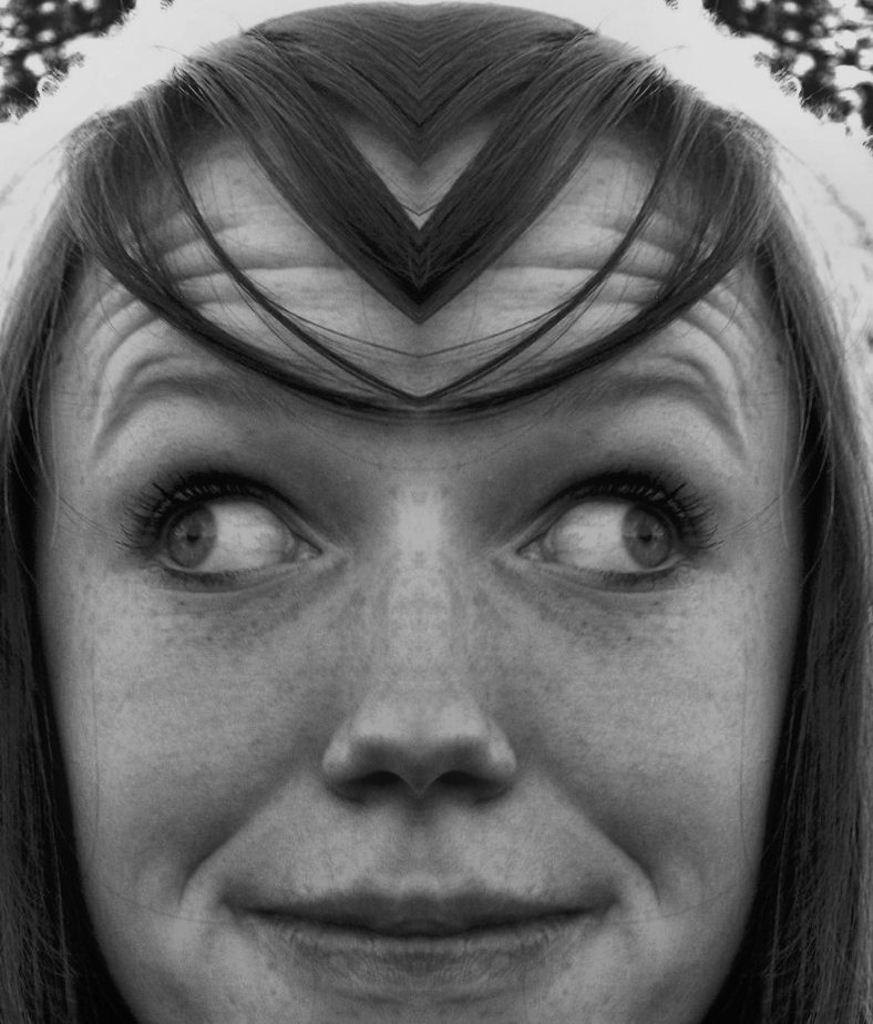Who is present in the image? There is a woman in the image. What is the woman's facial expression? The woman is smiling. What type of linen is the woman using to clean her throat in the image? There is no indication in the image that the woman is using linen or cleaning her throat, so it cannot be determined from the picture. 